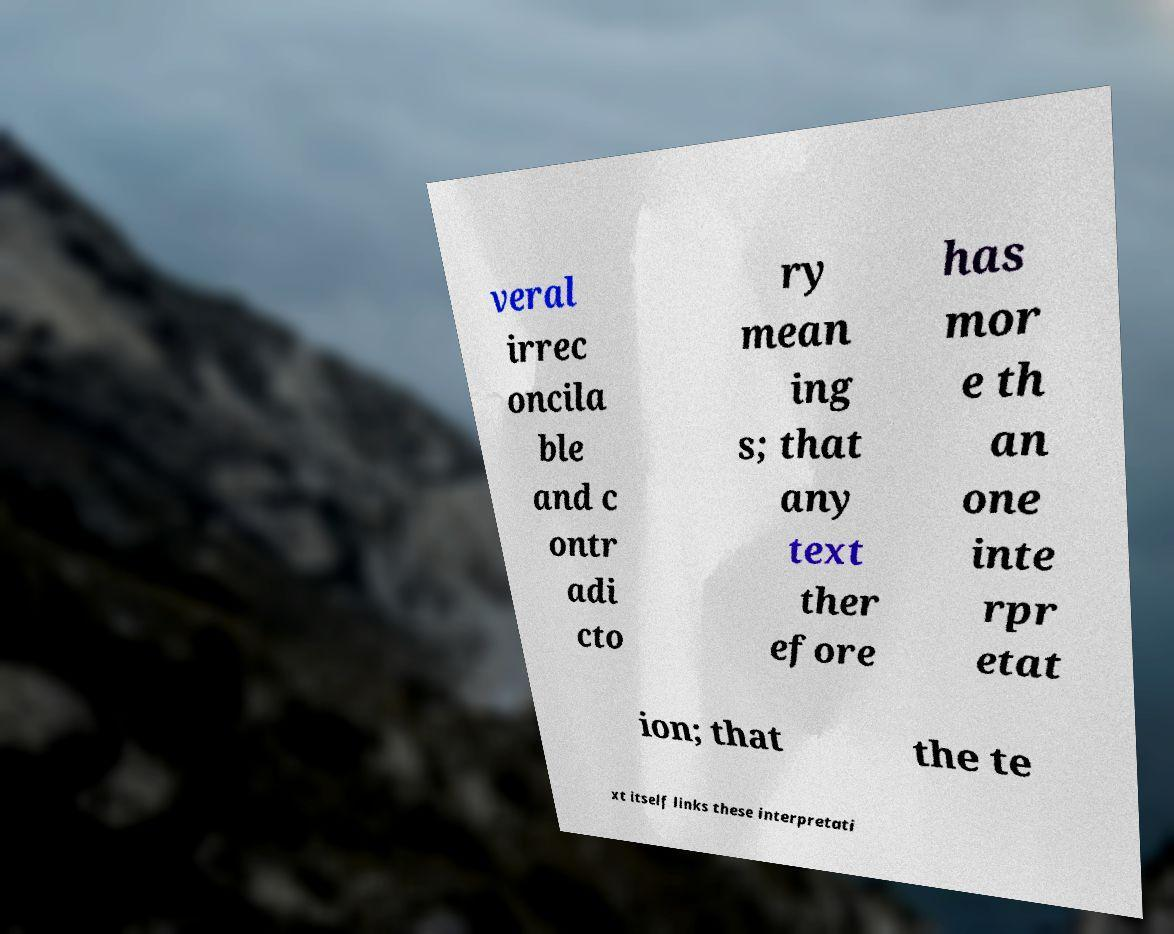I need the written content from this picture converted into text. Can you do that? veral irrec oncila ble and c ontr adi cto ry mean ing s; that any text ther efore has mor e th an one inte rpr etat ion; that the te xt itself links these interpretati 